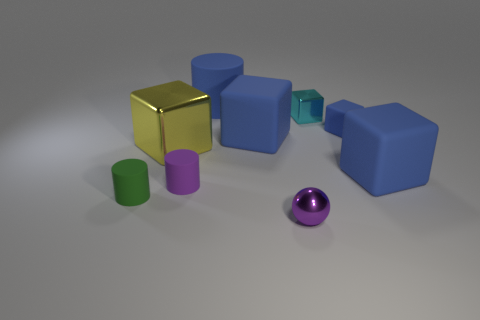How many blue blocks must be subtracted to get 1 blue blocks? 2 Subtract all red cylinders. How many blue blocks are left? 3 Subtract 1 cubes. How many cubes are left? 4 Subtract all cyan blocks. How many blocks are left? 4 Subtract all yellow cubes. How many cubes are left? 4 Subtract all purple cylinders. Subtract all cyan blocks. How many cylinders are left? 2 Subtract all balls. How many objects are left? 8 Add 7 green objects. How many green objects exist? 8 Subtract 0 purple blocks. How many objects are left? 9 Subtract all large metallic things. Subtract all blue objects. How many objects are left? 4 